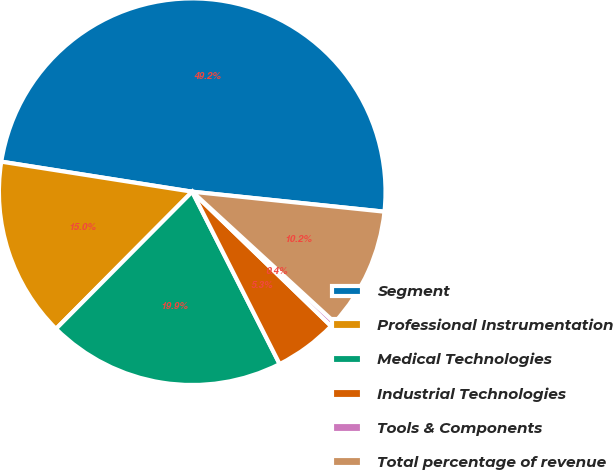<chart> <loc_0><loc_0><loc_500><loc_500><pie_chart><fcel>Segment<fcel>Professional Instrumentation<fcel>Medical Technologies<fcel>Industrial Technologies<fcel>Tools & Components<fcel>Total percentage of revenue<nl><fcel>49.17%<fcel>15.04%<fcel>19.92%<fcel>5.29%<fcel>0.42%<fcel>10.17%<nl></chart> 